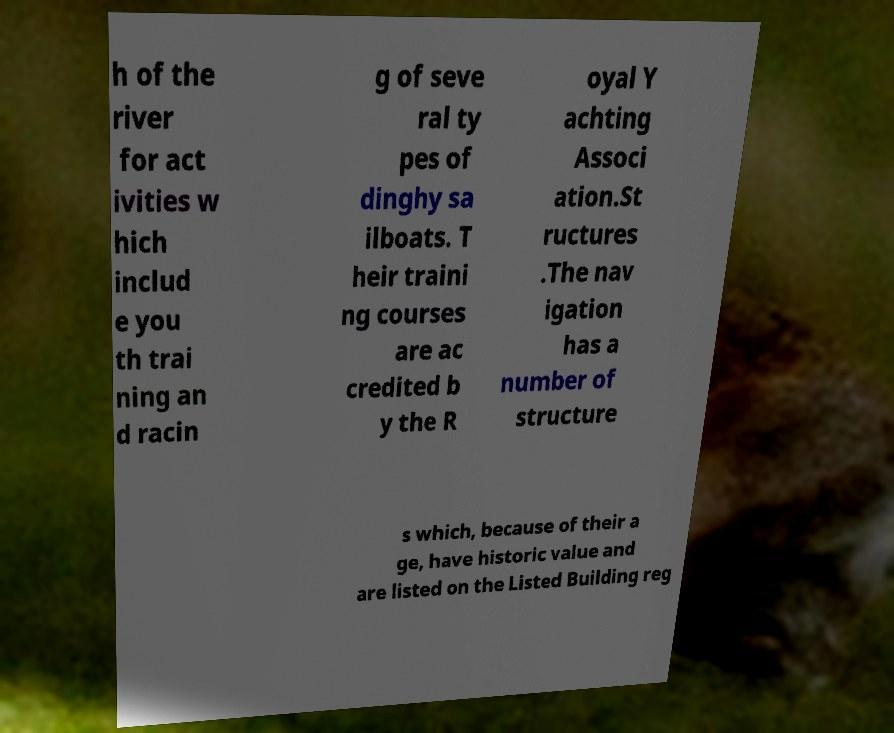Please read and relay the text visible in this image. What does it say? h of the river for act ivities w hich includ e you th trai ning an d racin g of seve ral ty pes of dinghy sa ilboats. T heir traini ng courses are ac credited b y the R oyal Y achting Associ ation.St ructures .The nav igation has a number of structure s which, because of their a ge, have historic value and are listed on the Listed Building reg 